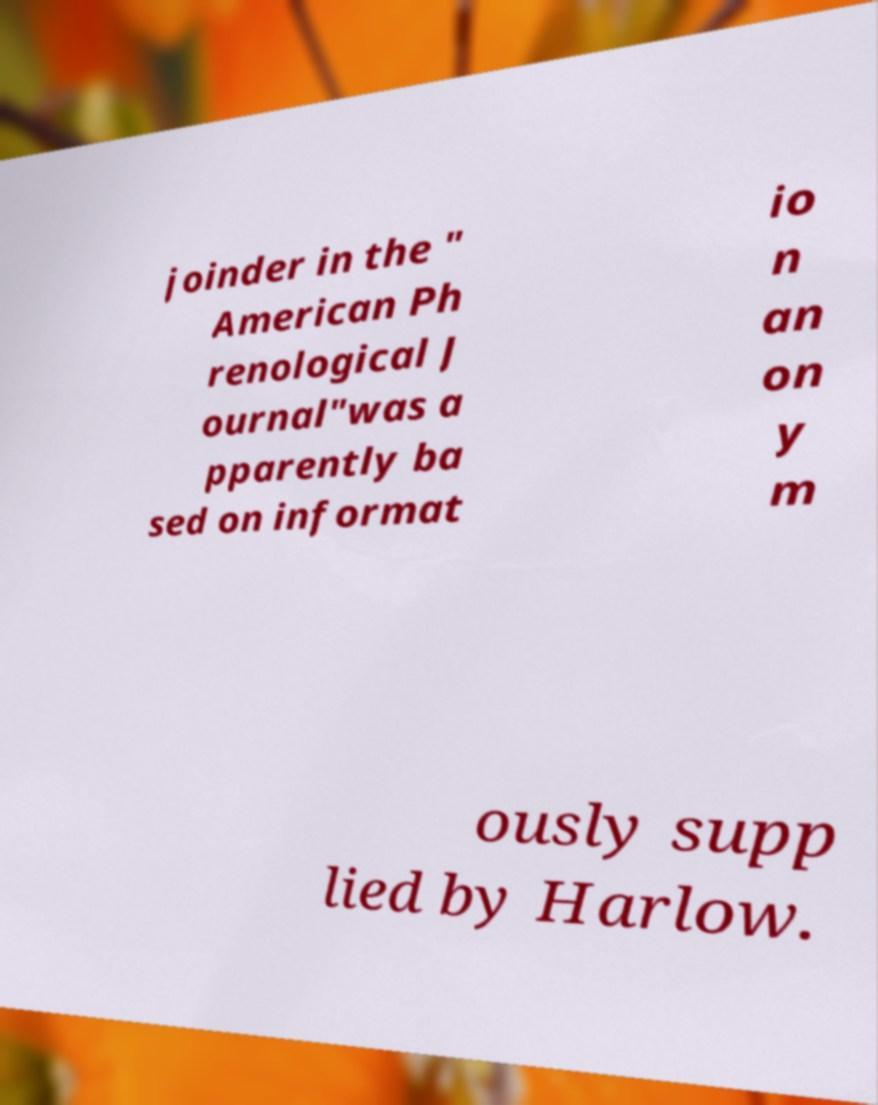Can you accurately transcribe the text from the provided image for me? joinder in the " American Ph renological J ournal"was a pparently ba sed on informat io n an on y m ously supp lied by Harlow. 